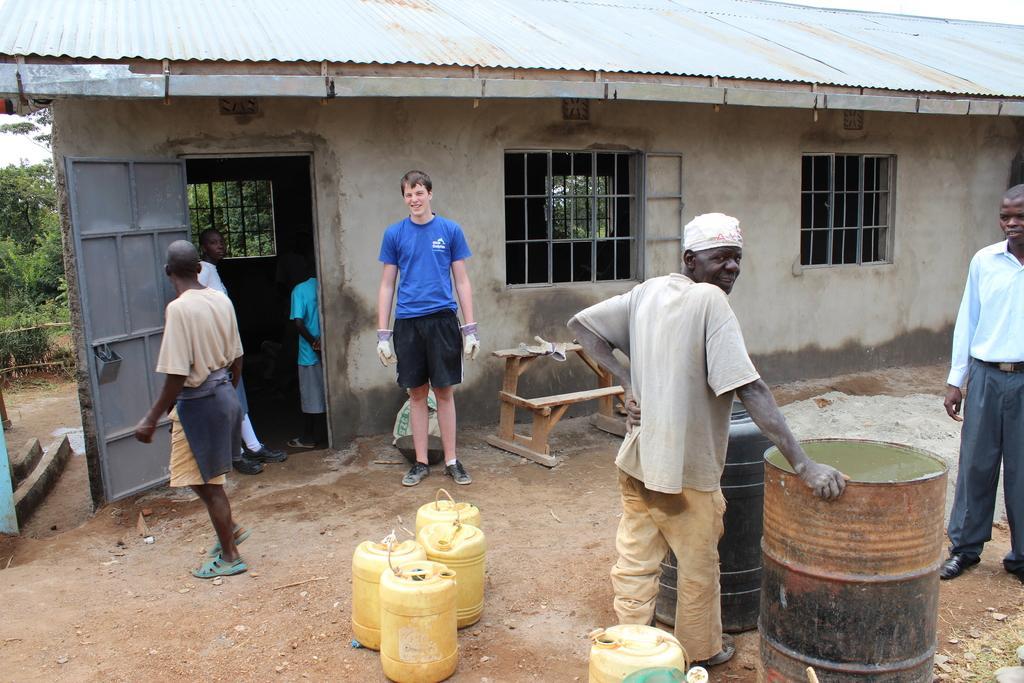Describe this image in one or two sentences. In the middle a man is standing, he wore a blue color t-shirt. Right side another man is standing, placing his hand on a drum and here it is a house under construction. 